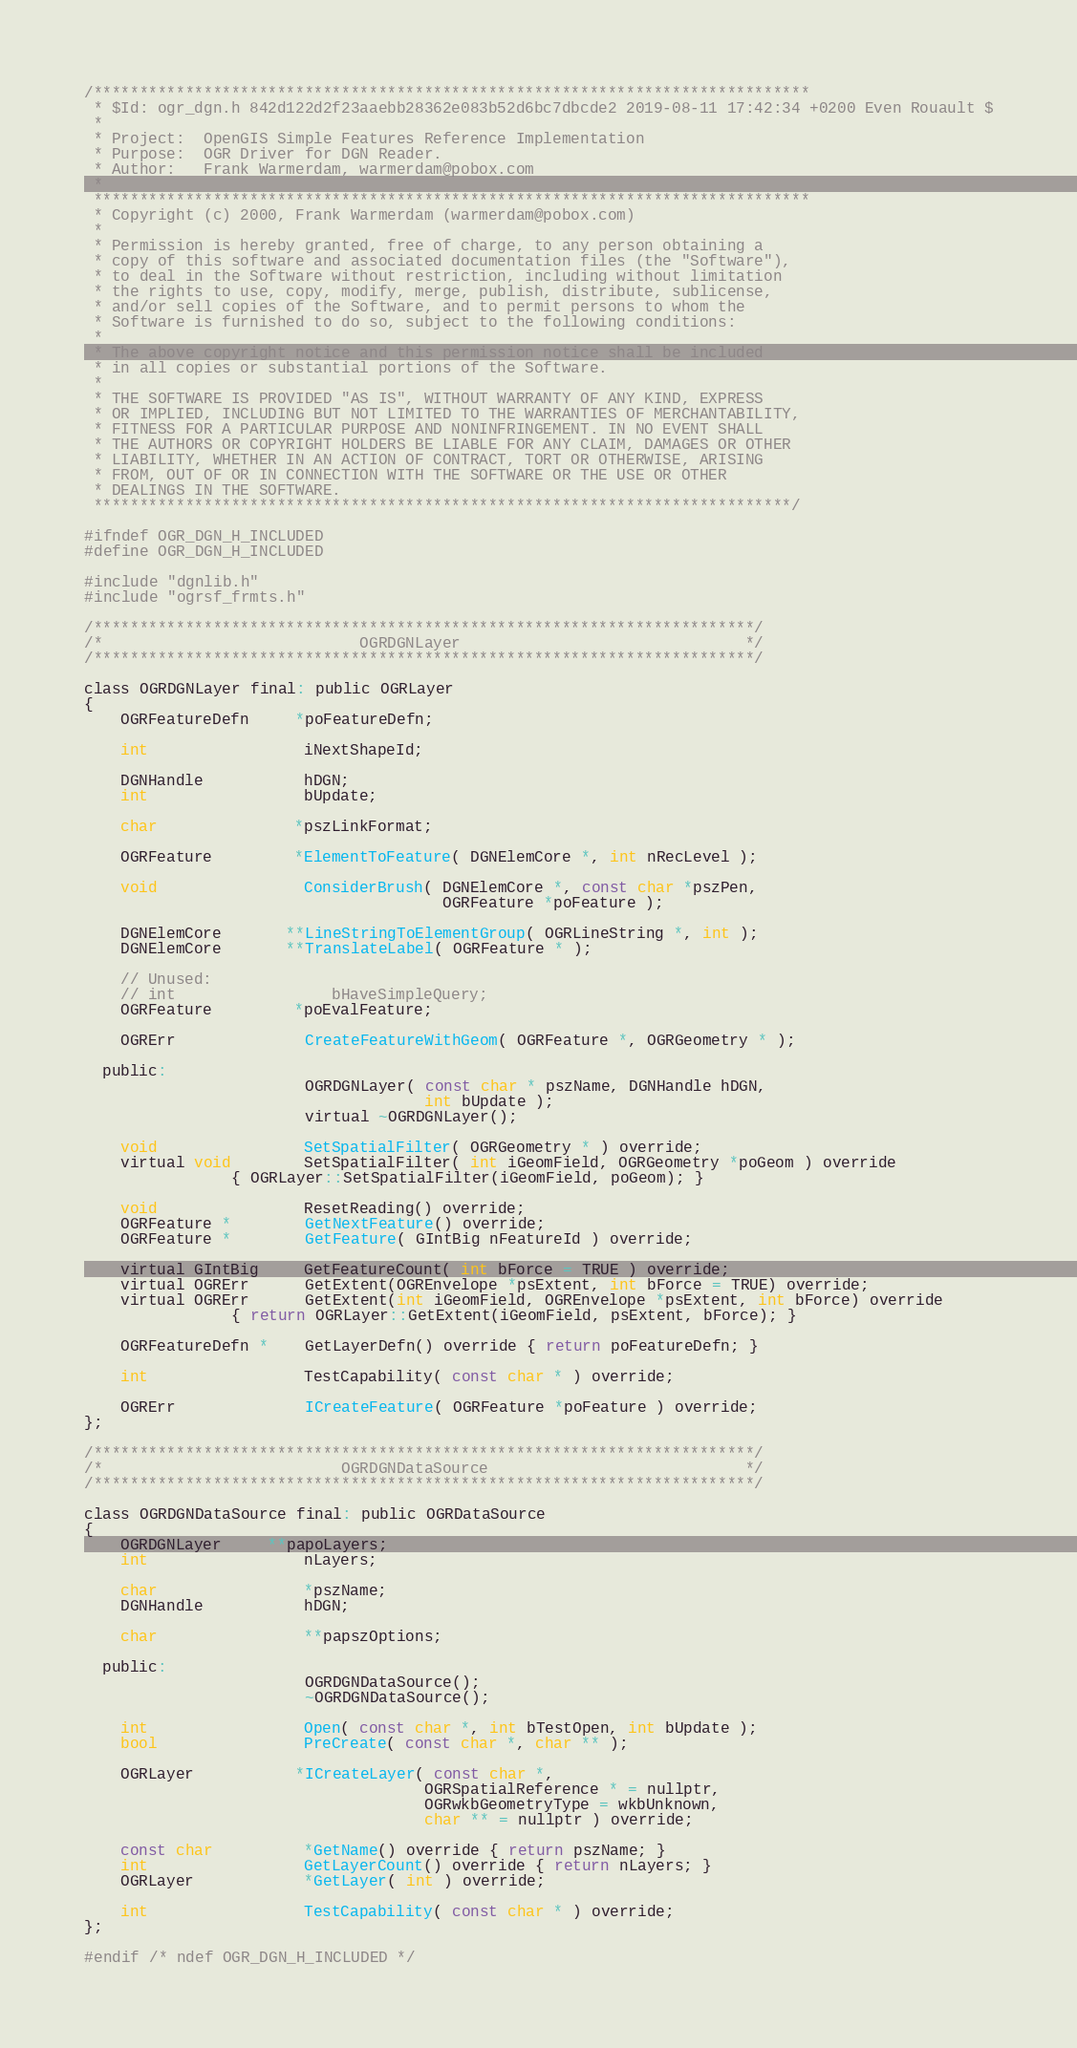<code> <loc_0><loc_0><loc_500><loc_500><_C_>/******************************************************************************
 * $Id: ogr_dgn.h 842d122d2f23aaebb28362e083b52d6bc7dbcde2 2019-08-11 17:42:34 +0200 Even Rouault $
 *
 * Project:  OpenGIS Simple Features Reference Implementation
 * Purpose:  OGR Driver for DGN Reader.
 * Author:   Frank Warmerdam, warmerdam@pobox.com
 *
 ******************************************************************************
 * Copyright (c) 2000, Frank Warmerdam (warmerdam@pobox.com)
 *
 * Permission is hereby granted, free of charge, to any person obtaining a
 * copy of this software and associated documentation files (the "Software"),
 * to deal in the Software without restriction, including without limitation
 * the rights to use, copy, modify, merge, publish, distribute, sublicense,
 * and/or sell copies of the Software, and to permit persons to whom the
 * Software is furnished to do so, subject to the following conditions:
 *
 * The above copyright notice and this permission notice shall be included
 * in all copies or substantial portions of the Software.
 *
 * THE SOFTWARE IS PROVIDED "AS IS", WITHOUT WARRANTY OF ANY KIND, EXPRESS
 * OR IMPLIED, INCLUDING BUT NOT LIMITED TO THE WARRANTIES OF MERCHANTABILITY,
 * FITNESS FOR A PARTICULAR PURPOSE AND NONINFRINGEMENT. IN NO EVENT SHALL
 * THE AUTHORS OR COPYRIGHT HOLDERS BE LIABLE FOR ANY CLAIM, DAMAGES OR OTHER
 * LIABILITY, WHETHER IN AN ACTION OF CONTRACT, TORT OR OTHERWISE, ARISING
 * FROM, OUT OF OR IN CONNECTION WITH THE SOFTWARE OR THE USE OR OTHER
 * DEALINGS IN THE SOFTWARE.
 ****************************************************************************/

#ifndef OGR_DGN_H_INCLUDED
#define OGR_DGN_H_INCLUDED

#include "dgnlib.h"
#include "ogrsf_frmts.h"

/************************************************************************/
/*                            OGRDGNLayer                               */
/************************************************************************/

class OGRDGNLayer final: public OGRLayer
{
    OGRFeatureDefn     *poFeatureDefn;

    int                 iNextShapeId;

    DGNHandle           hDGN;
    int                 bUpdate;

    char               *pszLinkFormat;

    OGRFeature         *ElementToFeature( DGNElemCore *, int nRecLevel );

    void                ConsiderBrush( DGNElemCore *, const char *pszPen,
                                       OGRFeature *poFeature );

    DGNElemCore       **LineStringToElementGroup( OGRLineString *, int );
    DGNElemCore       **TranslateLabel( OGRFeature * );

    // Unused:
    // int                 bHaveSimpleQuery;
    OGRFeature         *poEvalFeature;

    OGRErr              CreateFeatureWithGeom( OGRFeature *, OGRGeometry * );

  public:
                        OGRDGNLayer( const char * pszName, DGNHandle hDGN,
                                     int bUpdate );
                        virtual ~OGRDGNLayer();

    void                SetSpatialFilter( OGRGeometry * ) override;
    virtual void        SetSpatialFilter( int iGeomField, OGRGeometry *poGeom ) override
                { OGRLayer::SetSpatialFilter(iGeomField, poGeom); }

    void                ResetReading() override;
    OGRFeature *        GetNextFeature() override;
    OGRFeature *        GetFeature( GIntBig nFeatureId ) override;

    virtual GIntBig     GetFeatureCount( int bForce = TRUE ) override;
    virtual OGRErr      GetExtent(OGREnvelope *psExtent, int bForce = TRUE) override;
    virtual OGRErr      GetExtent(int iGeomField, OGREnvelope *psExtent, int bForce) override
                { return OGRLayer::GetExtent(iGeomField, psExtent, bForce); }

    OGRFeatureDefn *    GetLayerDefn() override { return poFeatureDefn; }

    int                 TestCapability( const char * ) override;

    OGRErr              ICreateFeature( OGRFeature *poFeature ) override;
};

/************************************************************************/
/*                          OGRDGNDataSource                            */
/************************************************************************/

class OGRDGNDataSource final: public OGRDataSource
{
    OGRDGNLayer     **papoLayers;
    int                 nLayers;

    char                *pszName;
    DGNHandle           hDGN;

    char                **papszOptions;

  public:
                        OGRDGNDataSource();
                        ~OGRDGNDataSource();

    int                 Open( const char *, int bTestOpen, int bUpdate );
    bool                PreCreate( const char *, char ** );

    OGRLayer           *ICreateLayer( const char *,
                                     OGRSpatialReference * = nullptr,
                                     OGRwkbGeometryType = wkbUnknown,
                                     char ** = nullptr ) override;

    const char          *GetName() override { return pszName; }
    int                 GetLayerCount() override { return nLayers; }
    OGRLayer            *GetLayer( int ) override;

    int                 TestCapability( const char * ) override;
};

#endif /* ndef OGR_DGN_H_INCLUDED */
</code> 